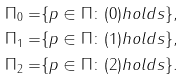<formula> <loc_0><loc_0><loc_500><loc_500>\Pi _ { 0 } = & \{ p \in \Pi \colon ( 0 ) h o l d s \} , \\ \Pi _ { 1 } = & \{ p \in \Pi \colon ( 1 ) h o l d s \} , \\ \Pi _ { 2 } = & \{ p \in \Pi \colon ( 2 ) h o l d s \} .</formula> 